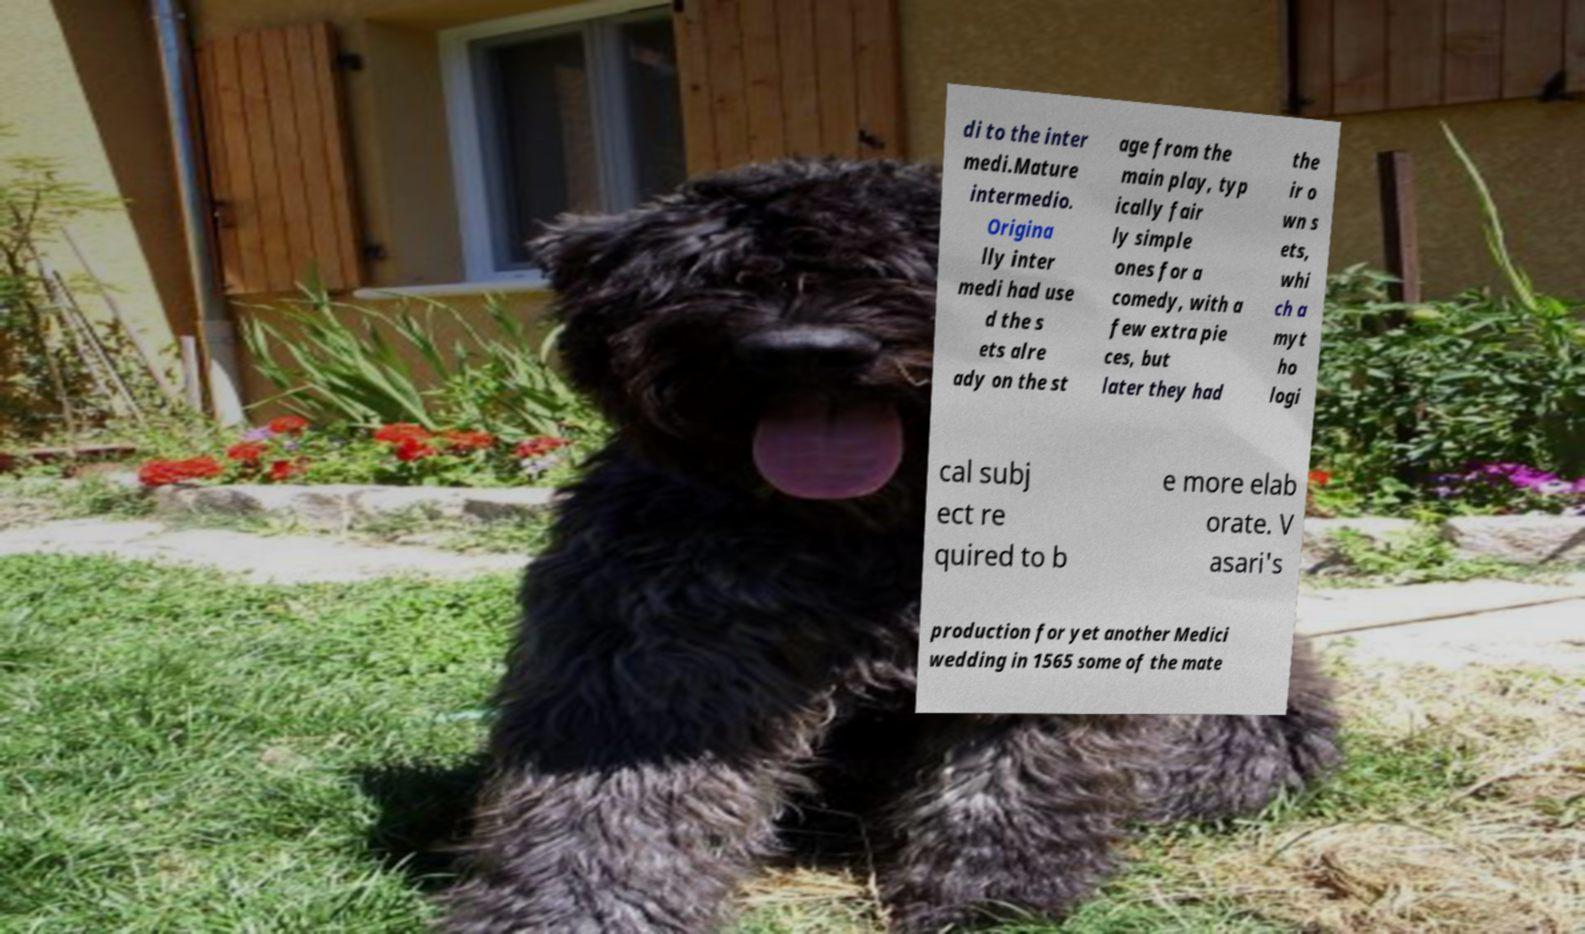What messages or text are displayed in this image? I need them in a readable, typed format. di to the inter medi.Mature intermedio. Origina lly inter medi had use d the s ets alre ady on the st age from the main play, typ ically fair ly simple ones for a comedy, with a few extra pie ces, but later they had the ir o wn s ets, whi ch a myt ho logi cal subj ect re quired to b e more elab orate. V asari's production for yet another Medici wedding in 1565 some of the mate 